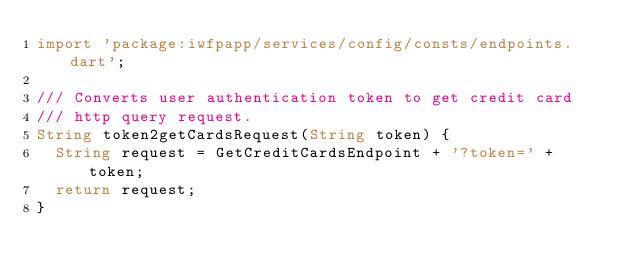<code> <loc_0><loc_0><loc_500><loc_500><_Dart_>import 'package:iwfpapp/services/config/consts/endpoints.dart';

/// Converts user authentication token to get credit card
/// http query request.
String token2getCardsRequest(String token) {
  String request = GetCreditCardsEndpoint + '?token=' + token;
  return request;
}
</code> 